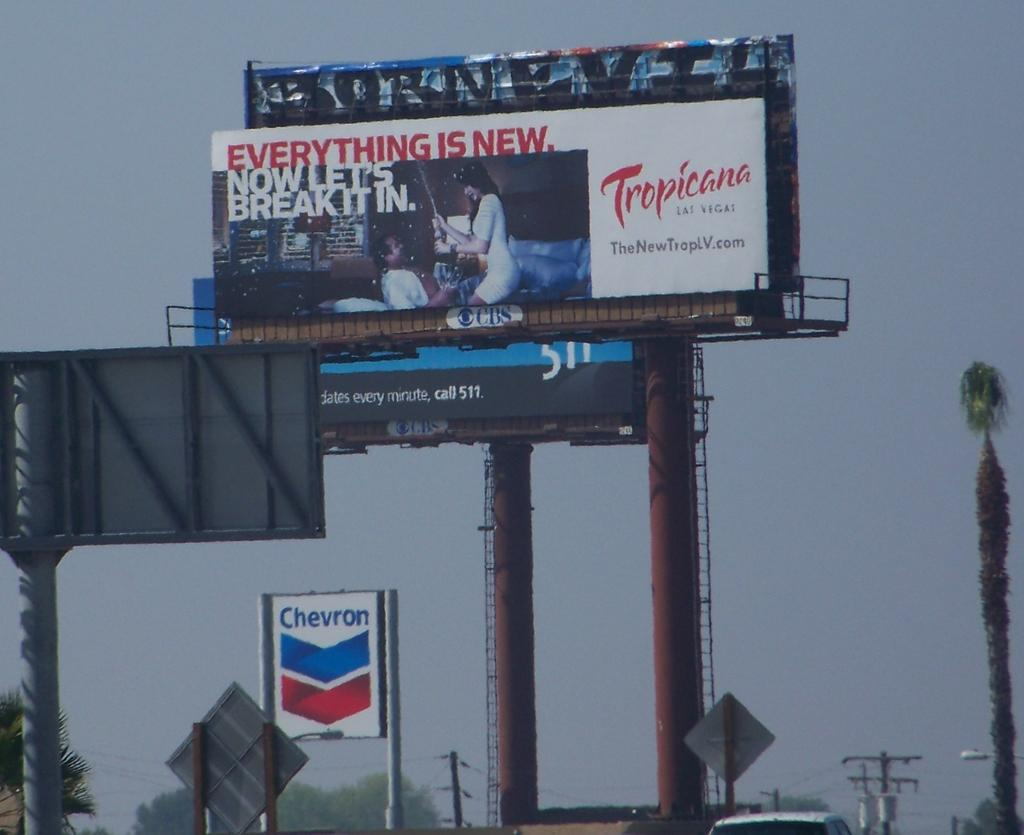<image>
Summarize the visual content of the image. A large billboard is above a Chevron gas station sign. 